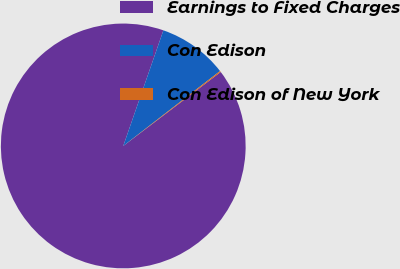Convert chart to OTSL. <chart><loc_0><loc_0><loc_500><loc_500><pie_chart><fcel>Earnings to Fixed Charges<fcel>Con Edison<fcel>Con Edison of New York<nl><fcel>90.65%<fcel>9.2%<fcel>0.15%<nl></chart> 